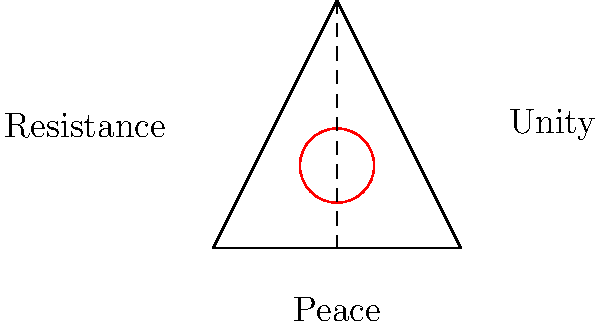In the context of activist art movements, what does the combination of a triangle, circle, and vertical line typically symbolize? To answer this question, let's analyze the components of the image and their symbolic meanings in activist art:

1. Triangle: In activist art, triangles often represent stability, strength, and unity. The base of the triangle symbolizes a strong foundation, while the point represents a focused goal or direction.

2. Circle: Circles are universal symbols of unity, wholeness, and inclusion. In activist movements, they often represent solidarity and the idea of a global community.

3. Vertical line: A vertical line bisecting the triangle suggests balance and equality. It can also represent a path or journey towards a goal.

4. Combination: When these elements are combined, they create a powerful symbol that embodies several key concepts in activist movements:

   a) The triangle provides a sense of stability and direction.
   b) The circle, placed at the top of the triangle, suggests that unity and inclusion are the ultimate goals.
   c) The vertical line connects the base (foundation) to the circle (goal), implying a journey or process.

5. Historical context: This symbol, or variations of it, has been used in various peace and social justice movements. It's reminiscent of the peace symbol but with additional layers of meaning.

6. Interpretation: Given these elements, the symbol can be interpreted as representing the journey from a stable foundation (triangle base) towards a unified, inclusive world (circle), with balance and equality (vertical line) as guiding principles.

Considering the context of activist art movements and the symbolic meanings of these geometric shapes, the most appropriate interpretation of this combination is a symbol for peace and unity through resistance or activism.
Answer: Peace and unity through resistance 